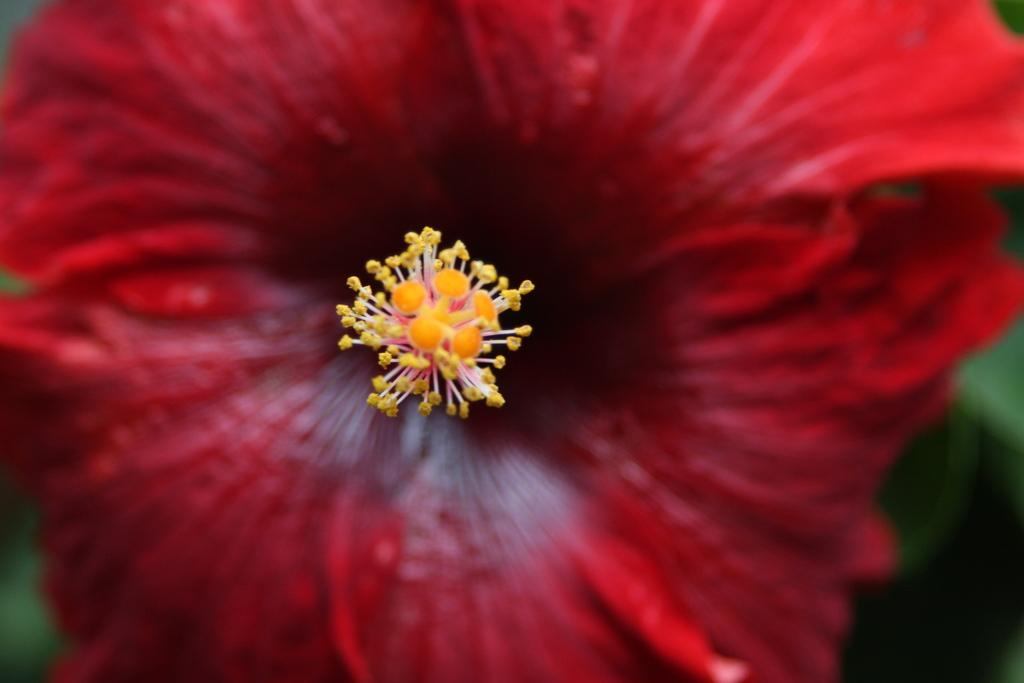What type of flower is in the picture? There is a red rose in the picture. Can you describe a specific part of the rose that is visible? The anther is visible in the center of the rose. What industry is represented by the riddle in the picture? There is no riddle or industry represented in the picture; it only features a red rose with a visible anther. 